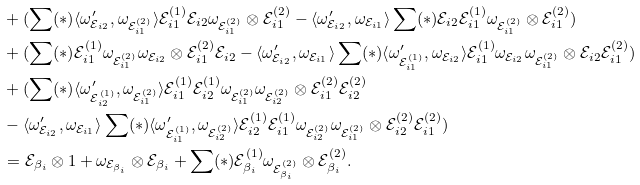<formula> <loc_0><loc_0><loc_500><loc_500>& + ( \sum ( * ) \langle \omega ^ { \prime } _ { { \mathcal { E } } _ { i 2 } } , \omega _ { { \mathcal { E } } _ { i 1 } ^ { ( 2 ) } } \rangle { \mathcal { E } } _ { i 1 } ^ { ( 1 ) } { \mathcal { E } } _ { i 2 } \omega _ { { \mathcal { E } } _ { i 1 } ^ { ( 2 ) } } \otimes { \mathcal { E } } _ { i 1 } ^ { ( 2 ) } - \langle \omega ^ { \prime } _ { { \mathcal { E } } _ { i 2 } } , \omega _ { { \mathcal { E } } _ { i 1 } } \rangle \sum ( * ) { \mathcal { E } } _ { i 2 } { \mathcal { E } } _ { i 1 } ^ { ( 1 ) } \omega _ { { \mathcal { E } } _ { i 1 } ^ { ( 2 ) } } \otimes { \mathcal { E } } _ { i 1 } ^ { ( 2 ) } ) \\ & + ( \sum ( * ) { \mathcal { E } } _ { i 1 } ^ { ( 1 ) } \omega _ { { \mathcal { E } } _ { i 1 } ^ { ( 2 ) } } \omega _ { { \mathcal { E } } _ { i 2 } } \otimes { \mathcal { E } } _ { i 1 } ^ { ( 2 ) } { \mathcal { E } } _ { i 2 } - \langle \omega ^ { \prime } _ { { \mathcal { E } } _ { i 2 } } , \omega _ { { \mathcal { E } } _ { i 1 } } \rangle \sum ( * ) \langle \omega ^ { \prime } _ { { \mathcal { E } } _ { i 1 } ^ { ( 1 ) } } , \omega _ { { \mathcal { E } } _ { i 2 } } \rangle { \mathcal { E } } _ { i 1 } ^ { ( 1 ) } \omega _ { { \mathcal { E } } _ { i 2 } } \omega _ { { \mathcal { E } } _ { i 1 } ^ { ( 2 ) } } \otimes { \mathcal { E } } _ { i 2 } { \mathcal { E } } _ { i 1 } ^ { ( 2 ) } ) \\ & + ( \sum ( * ) \langle \omega ^ { \prime } _ { { \mathcal { E } } _ { i 2 } ^ { ( 1 ) } } , \omega _ { { \mathcal { E } } _ { i 1 } ^ { ( 2 ) } } \rangle { \mathcal { E } } _ { i 1 } ^ { ( 1 ) } { \mathcal { E } } _ { i 2 } ^ { ( 1 ) } \omega _ { { \mathcal { E } } _ { i 1 } ^ { ( 2 ) } } \omega _ { { \mathcal { E } } _ { i 2 } ^ { ( 2 ) } } \otimes { \mathcal { E } } _ { i 1 } ^ { ( 2 ) } { \mathcal { E } } _ { i 2 } ^ { ( 2 ) } \\ & - \langle \omega ^ { \prime } _ { { \mathcal { E } } _ { i 2 } } , \omega _ { { \mathcal { E } } _ { i 1 } } \rangle \sum ( * ) \langle \omega ^ { \prime } _ { { \mathcal { E } } _ { i 1 } ^ { ( 1 ) } } , \omega _ { { \mathcal { E } } _ { i 2 } ^ { ( 2 ) } } \rangle { \mathcal { E } } _ { i 2 } ^ { ( 1 ) } { \mathcal { E } } _ { i 1 } ^ { ( 1 ) } \omega _ { { \mathcal { E } } _ { i 2 } ^ { ( 2 ) } } \omega _ { { \mathcal { E } } _ { i 1 } ^ { ( 2 ) } } \otimes { \mathcal { E } } _ { i 2 } ^ { ( 2 ) } { \mathcal { E } } _ { i 1 } ^ { ( 2 ) } ) \\ & = { \mathcal { E } } _ { \beta _ { i } } \otimes 1 + \omega _ { { \mathcal { E } } _ { \beta _ { i } } } \otimes { \mathcal { E } } _ { \beta _ { i } } + \sum ( * ) { \mathcal { E } } _ { \beta _ { i } } ^ { ( 1 ) } \omega _ { { \mathcal { E } } _ { \beta _ { i } } ^ { ( 2 ) } } \otimes { \mathcal { E } } _ { \beta _ { i } } ^ { ( 2 ) } .</formula> 